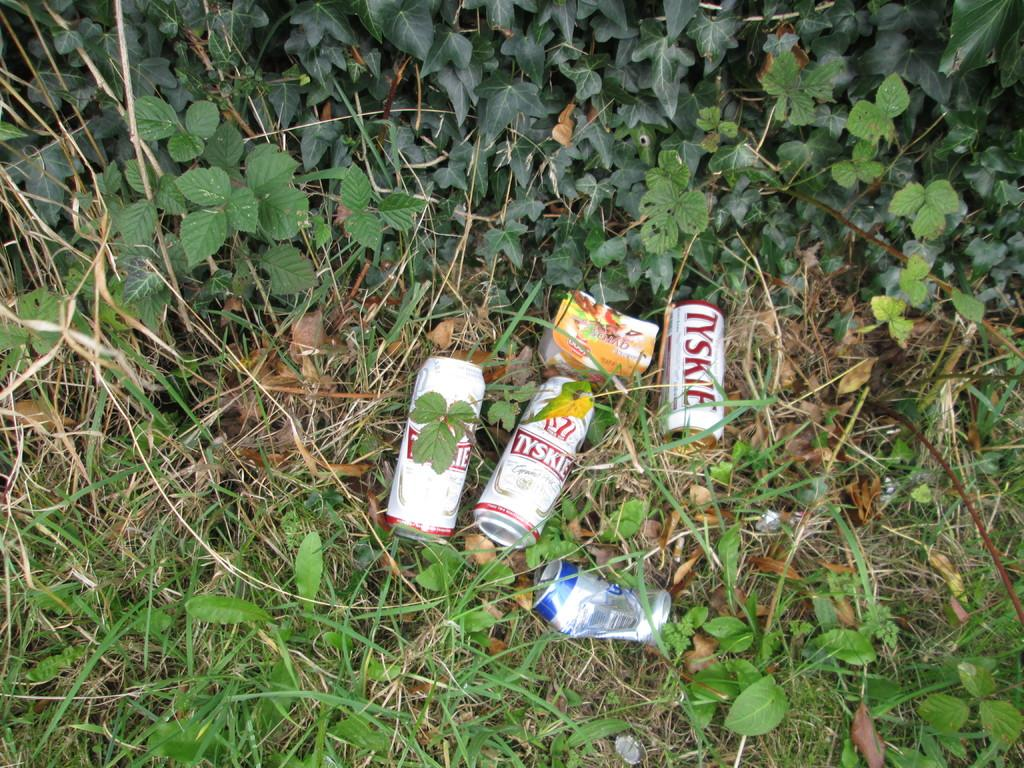How many tins are visible in the image? There are three tins in the image. What other container can be seen in the image besides the tins? There is one bottle in the image. Where are the tins and bottle placed in the image? The tins and bottle are placed on grass in the image. What type of vegetation is present in the image? There are plants in the image. What type of mitten can be seen on the bottle in the image? There is no mitten present on the bottle or any other object in the image. What material is the lead made of in the image? There is no lead present in the image. 